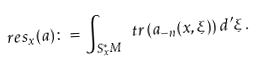<formula> <loc_0><loc_0><loc_500><loc_500>\ r e s _ { x } ( a ) \colon = \int _ { S _ { x } ^ { * } M } \ t r \left ( a _ { - n } ( x , \xi ) \right ) d ^ { \prime } \xi \, .</formula> 